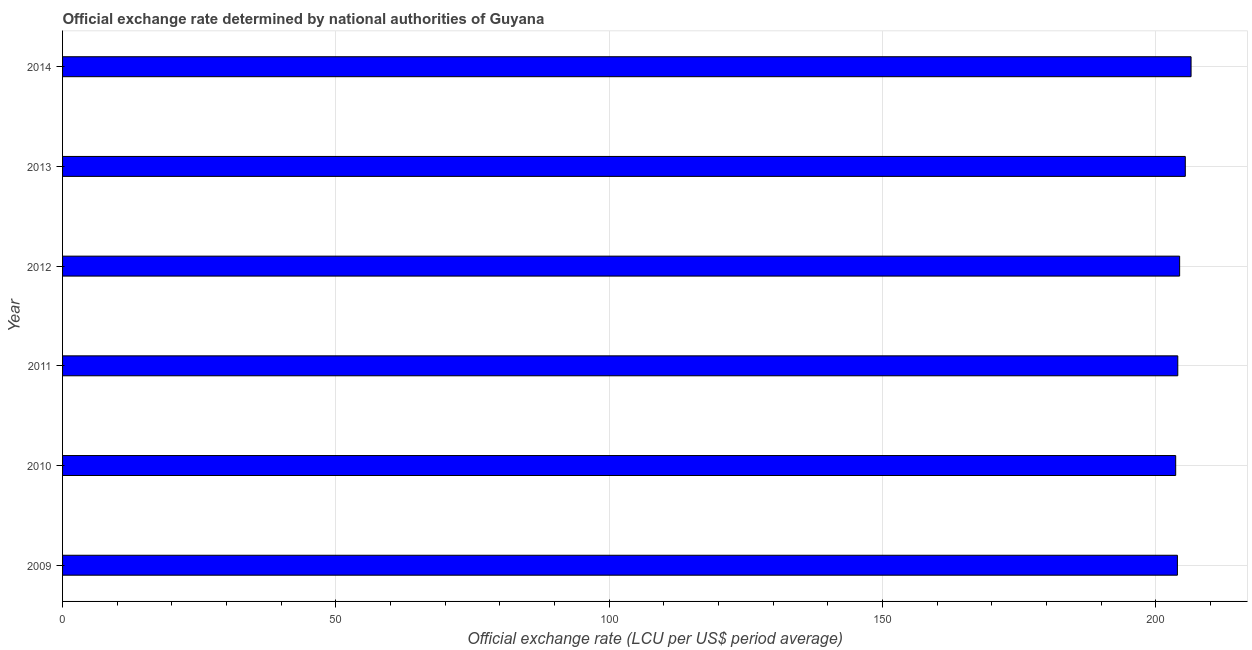Does the graph contain any zero values?
Keep it short and to the point. No. Does the graph contain grids?
Keep it short and to the point. Yes. What is the title of the graph?
Give a very brief answer. Official exchange rate determined by national authorities of Guyana. What is the label or title of the X-axis?
Give a very brief answer. Official exchange rate (LCU per US$ period average). What is the official exchange rate in 2011?
Offer a terse response. 204.02. Across all years, what is the maximum official exchange rate?
Ensure brevity in your answer.  206.45. Across all years, what is the minimum official exchange rate?
Your response must be concise. 203.64. In which year was the official exchange rate minimum?
Offer a terse response. 2010. What is the sum of the official exchange rate?
Provide a succinct answer. 1227.81. What is the difference between the official exchange rate in 2010 and 2014?
Keep it short and to the point. -2.81. What is the average official exchange rate per year?
Ensure brevity in your answer.  204.63. What is the median official exchange rate?
Your response must be concise. 204.19. What is the difference between the highest and the second highest official exchange rate?
Your answer should be compact. 1.05. Is the sum of the official exchange rate in 2009 and 2010 greater than the maximum official exchange rate across all years?
Give a very brief answer. Yes. What is the difference between the highest and the lowest official exchange rate?
Give a very brief answer. 2.81. Are the values on the major ticks of X-axis written in scientific E-notation?
Offer a very short reply. No. What is the Official exchange rate (LCU per US$ period average) of 2009?
Provide a short and direct response. 203.95. What is the Official exchange rate (LCU per US$ period average) of 2010?
Give a very brief answer. 203.64. What is the Official exchange rate (LCU per US$ period average) of 2011?
Offer a very short reply. 204.02. What is the Official exchange rate (LCU per US$ period average) in 2012?
Your answer should be very brief. 204.36. What is the Official exchange rate (LCU per US$ period average) in 2013?
Keep it short and to the point. 205.39. What is the Official exchange rate (LCU per US$ period average) of 2014?
Provide a short and direct response. 206.45. What is the difference between the Official exchange rate (LCU per US$ period average) in 2009 and 2010?
Provide a short and direct response. 0.31. What is the difference between the Official exchange rate (LCU per US$ period average) in 2009 and 2011?
Your response must be concise. -0.07. What is the difference between the Official exchange rate (LCU per US$ period average) in 2009 and 2012?
Offer a terse response. -0.41. What is the difference between the Official exchange rate (LCU per US$ period average) in 2009 and 2013?
Provide a succinct answer. -1.44. What is the difference between the Official exchange rate (LCU per US$ period average) in 2009 and 2014?
Your answer should be compact. -2.5. What is the difference between the Official exchange rate (LCU per US$ period average) in 2010 and 2011?
Give a very brief answer. -0.38. What is the difference between the Official exchange rate (LCU per US$ period average) in 2010 and 2012?
Your answer should be very brief. -0.72. What is the difference between the Official exchange rate (LCU per US$ period average) in 2010 and 2013?
Your answer should be very brief. -1.76. What is the difference between the Official exchange rate (LCU per US$ period average) in 2010 and 2014?
Your response must be concise. -2.81. What is the difference between the Official exchange rate (LCU per US$ period average) in 2011 and 2012?
Keep it short and to the point. -0.34. What is the difference between the Official exchange rate (LCU per US$ period average) in 2011 and 2013?
Your answer should be compact. -1.38. What is the difference between the Official exchange rate (LCU per US$ period average) in 2011 and 2014?
Your response must be concise. -2.43. What is the difference between the Official exchange rate (LCU per US$ period average) in 2012 and 2013?
Provide a short and direct response. -1.04. What is the difference between the Official exchange rate (LCU per US$ period average) in 2012 and 2014?
Your answer should be compact. -2.09. What is the difference between the Official exchange rate (LCU per US$ period average) in 2013 and 2014?
Your answer should be very brief. -1.05. What is the ratio of the Official exchange rate (LCU per US$ period average) in 2009 to that in 2011?
Provide a succinct answer. 1. What is the ratio of the Official exchange rate (LCU per US$ period average) in 2009 to that in 2013?
Provide a succinct answer. 0.99. What is the ratio of the Official exchange rate (LCU per US$ period average) in 2009 to that in 2014?
Offer a terse response. 0.99. What is the ratio of the Official exchange rate (LCU per US$ period average) in 2010 to that in 2014?
Your answer should be very brief. 0.99. What is the ratio of the Official exchange rate (LCU per US$ period average) in 2011 to that in 2013?
Your response must be concise. 0.99. What is the ratio of the Official exchange rate (LCU per US$ period average) in 2011 to that in 2014?
Your answer should be very brief. 0.99. What is the ratio of the Official exchange rate (LCU per US$ period average) in 2012 to that in 2013?
Your answer should be very brief. 0.99. 